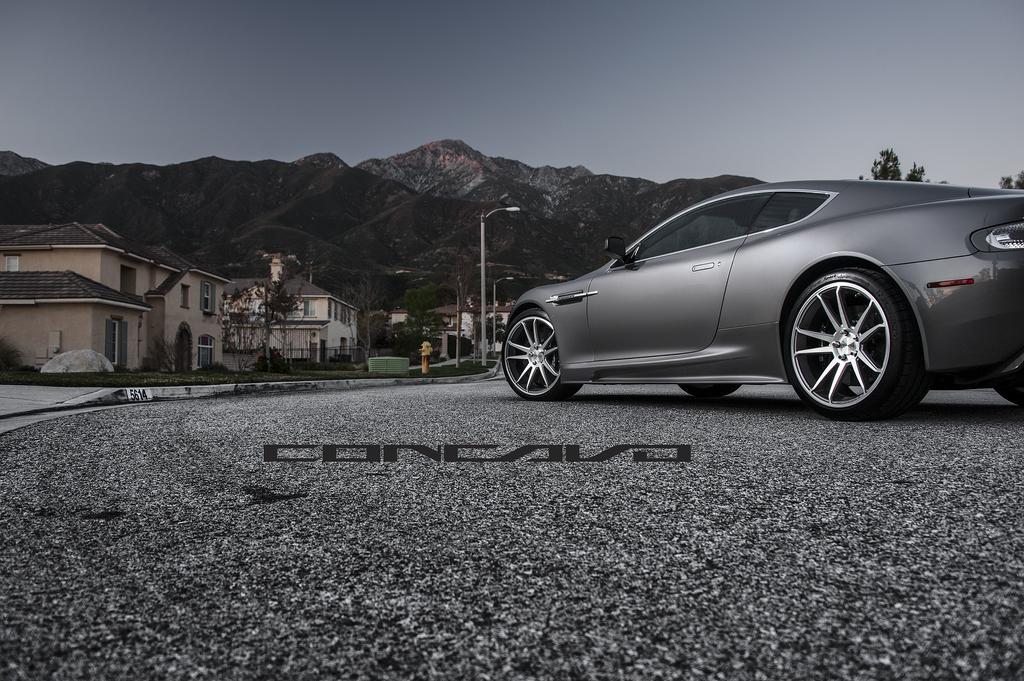Could you give a brief overview of what you see in this image? Here there is a car on the road. In the background there are buildings,trees,grass,some other objects,street lights,poles,mountains and sky. 